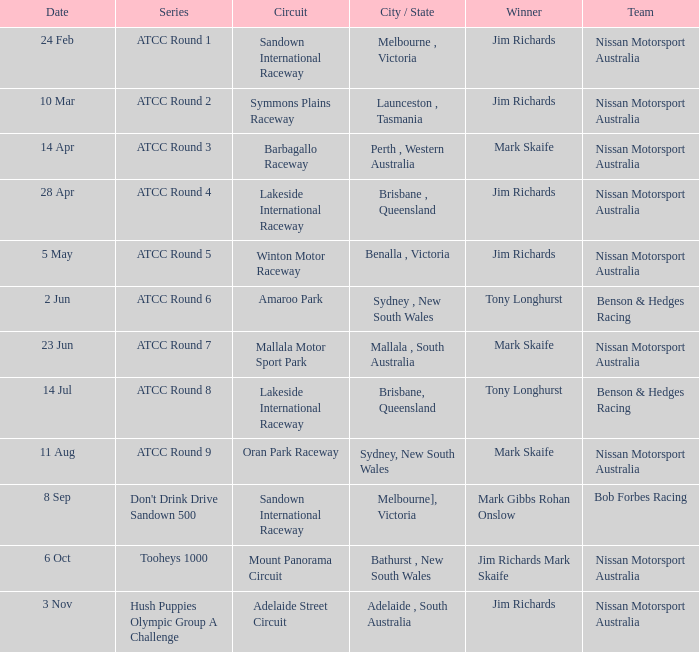What is the Circuit in the ATCC Round 1 Series with Winner Jim Richards? Sandown International Raceway. 